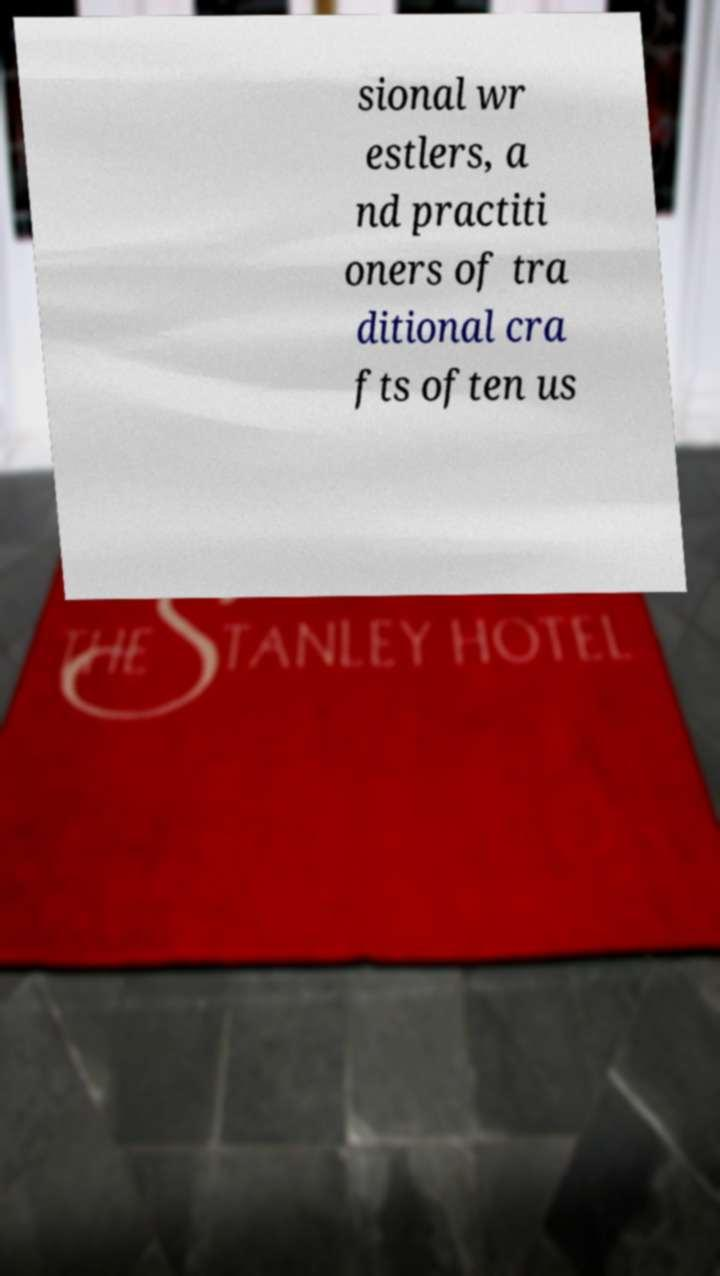I need the written content from this picture converted into text. Can you do that? sional wr estlers, a nd practiti oners of tra ditional cra fts often us 